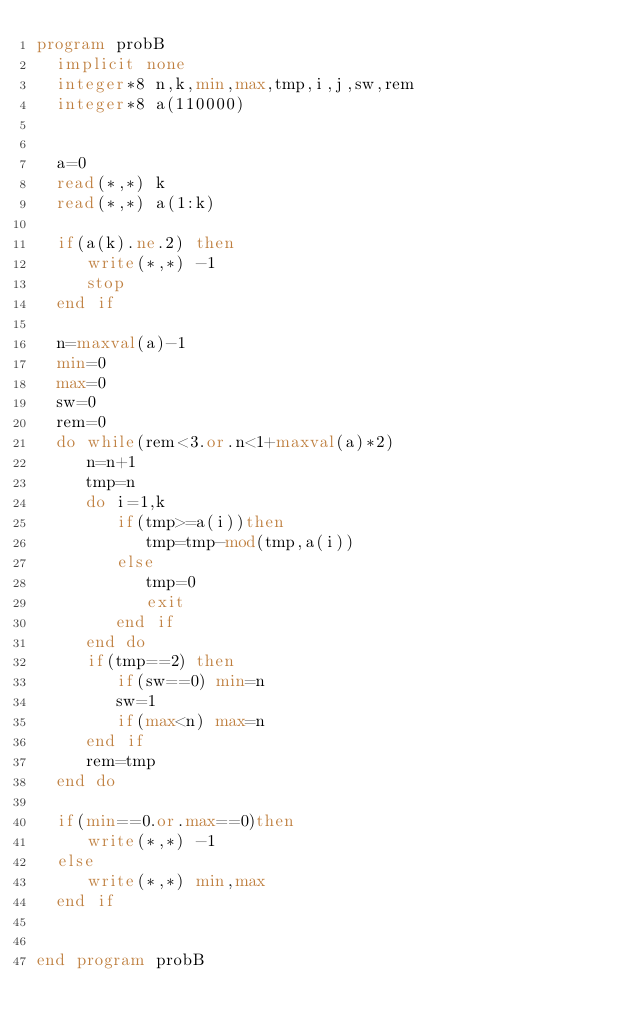<code> <loc_0><loc_0><loc_500><loc_500><_FORTRAN_>program probB
  implicit none
  integer*8 n,k,min,max,tmp,i,j,sw,rem
  integer*8 a(110000)
  

  a=0
  read(*,*) k
  read(*,*) a(1:k)

  if(a(k).ne.2) then
     write(*,*) -1
     stop
  end if
  
  n=maxval(a)-1
  min=0
  max=0
  sw=0
  rem=0
  do while(rem<3.or.n<1+maxval(a)*2)
     n=n+1
     tmp=n
     do i=1,k
        if(tmp>=a(i))then
           tmp=tmp-mod(tmp,a(i))
        else
           tmp=0
           exit 
        end if
     end do
     if(tmp==2) then
        if(sw==0) min=n
        sw=1
        if(max<n) max=n
     end if
     rem=tmp
  end do

  if(min==0.or.max==0)then
     write(*,*) -1
  else
     write(*,*) min,max
  end if
  
   
end program probB
</code> 